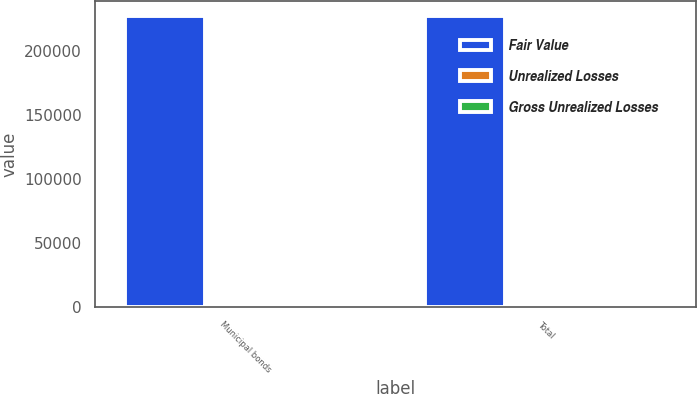Convert chart. <chart><loc_0><loc_0><loc_500><loc_500><stacked_bar_chart><ecel><fcel>Municipal bonds<fcel>Total<nl><fcel>Fair Value<fcel>227713<fcel>227713<nl><fcel>Unrealized Losses<fcel>455<fcel>455<nl><fcel>Gross Unrealized Losses<fcel>685<fcel>785<nl></chart> 